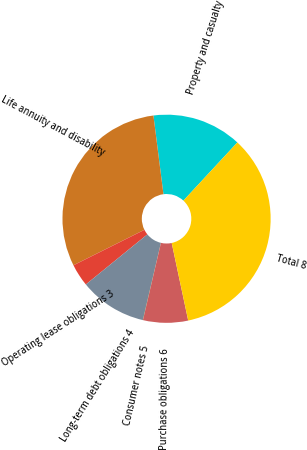Convert chart to OTSL. <chart><loc_0><loc_0><loc_500><loc_500><pie_chart><fcel>Property and casualty<fcel>Life annuity and disability<fcel>Operating lease obligations 3<fcel>Long-term debt obligations 4<fcel>Consumer notes 5<fcel>Purchase obligations 6<fcel>Total 8<nl><fcel>13.92%<fcel>30.36%<fcel>3.5%<fcel>10.45%<fcel>0.03%<fcel>6.98%<fcel>34.76%<nl></chart> 